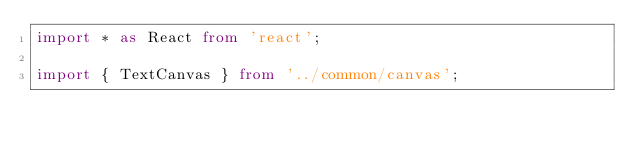Convert code to text. <code><loc_0><loc_0><loc_500><loc_500><_TypeScript_>import * as React from 'react';

import { TextCanvas } from '../common/canvas';</code> 